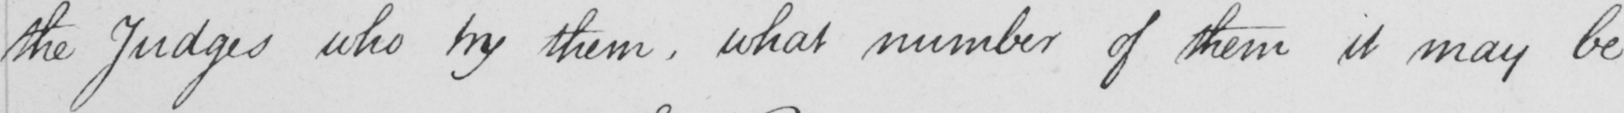Can you read and transcribe this handwriting? the Judges who try them , what number of them it may be 